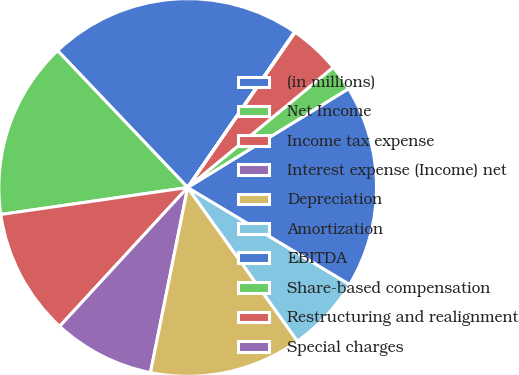<chart> <loc_0><loc_0><loc_500><loc_500><pie_chart><fcel>(in millions)<fcel>Net Income<fcel>Income tax expense<fcel>Interest expense (Income) net<fcel>Depreciation<fcel>Amortization<fcel>EBITDA<fcel>Share-based compensation<fcel>Restructuring and realignment<fcel>Special charges<nl><fcel>21.68%<fcel>15.19%<fcel>10.86%<fcel>8.7%<fcel>13.03%<fcel>6.54%<fcel>17.35%<fcel>2.22%<fcel>4.38%<fcel>0.05%<nl></chart> 